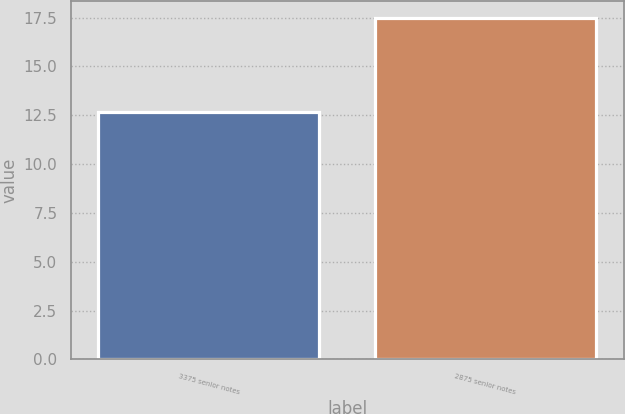Convert chart to OTSL. <chart><loc_0><loc_0><loc_500><loc_500><bar_chart><fcel>3375 senior notes<fcel>2875 senior notes<nl><fcel>12.66<fcel>17.49<nl></chart> 